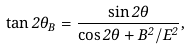Convert formula to latex. <formula><loc_0><loc_0><loc_500><loc_500>\tan 2 \theta _ { B } = \frac { \sin 2 \theta } { \cos 2 \theta + B ^ { 2 } / E ^ { 2 } } ,</formula> 